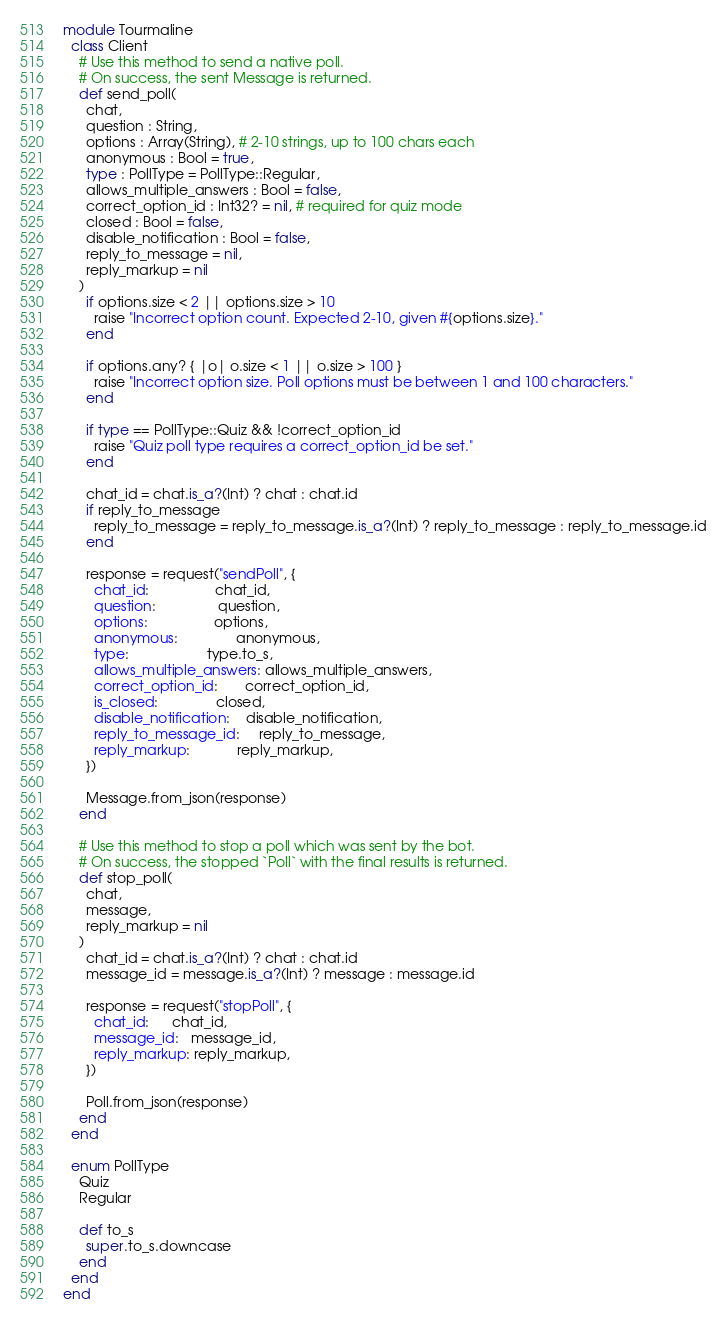Convert code to text. <code><loc_0><loc_0><loc_500><loc_500><_Crystal_>module Tourmaline
  class Client
    # Use this method to send a native poll.
    # On success, the sent Message is returned.
    def send_poll(
      chat,
      question : String,
      options : Array(String), # 2-10 strings, up to 100 chars each
      anonymous : Bool = true,
      type : PollType = PollType::Regular,
      allows_multiple_answers : Bool = false,
      correct_option_id : Int32? = nil, # required for quiz mode
      closed : Bool = false,
      disable_notification : Bool = false,
      reply_to_message = nil,
      reply_markup = nil
    )
      if options.size < 2 || options.size > 10
        raise "Incorrect option count. Expected 2-10, given #{options.size}."
      end

      if options.any? { |o| o.size < 1 || o.size > 100 }
        raise "Incorrect option size. Poll options must be between 1 and 100 characters."
      end

      if type == PollType::Quiz && !correct_option_id
        raise "Quiz poll type requires a correct_option_id be set."
      end

      chat_id = chat.is_a?(Int) ? chat : chat.id
      if reply_to_message
        reply_to_message = reply_to_message.is_a?(Int) ? reply_to_message : reply_to_message.id
      end

      response = request("sendPoll", {
        chat_id:                 chat_id,
        question:                question,
        options:                 options,
        anonymous:               anonymous,
        type:                    type.to_s,
        allows_multiple_answers: allows_multiple_answers,
        correct_option_id:       correct_option_id,
        is_closed:               closed,
        disable_notification:    disable_notification,
        reply_to_message_id:     reply_to_message,
        reply_markup:            reply_markup,
      })

      Message.from_json(response)
    end

    # Use this method to stop a poll which was sent by the bot.
    # On success, the stopped `Poll` with the final results is returned.
    def stop_poll(
      chat,
      message,
      reply_markup = nil
    )
      chat_id = chat.is_a?(Int) ? chat : chat.id
      message_id = message.is_a?(Int) ? message : message.id

      response = request("stopPoll", {
        chat_id:      chat_id,
        message_id:   message_id,
        reply_markup: reply_markup,
      })

      Poll.from_json(response)
    end
  end

  enum PollType
    Quiz
    Regular

    def to_s
      super.to_s.downcase
    end
  end
end
</code> 